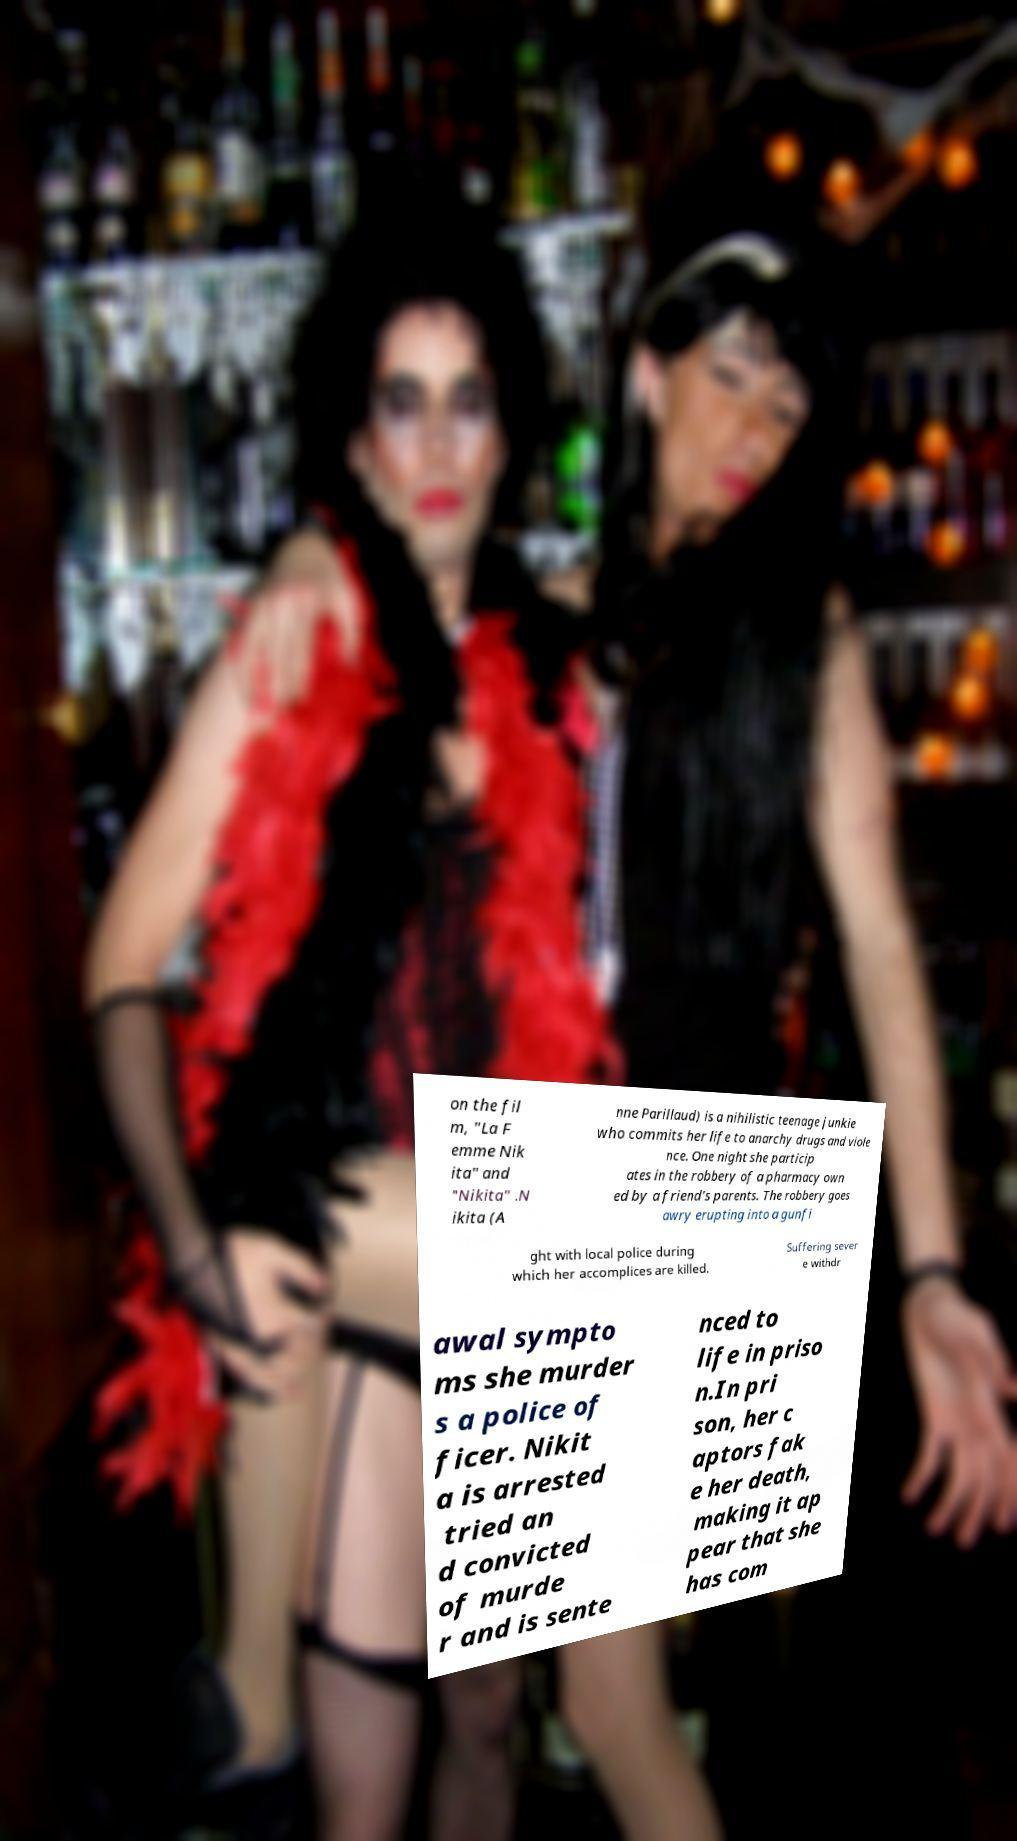Can you accurately transcribe the text from the provided image for me? on the fil m, "La F emme Nik ita" and "Nikita" .N ikita (A nne Parillaud) is a nihilistic teenage junkie who commits her life to anarchy drugs and viole nce. One night she particip ates in the robbery of a pharmacy own ed by a friend's parents. The robbery goes awry erupting into a gunfi ght with local police during which her accomplices are killed. Suffering sever e withdr awal sympto ms she murder s a police of ficer. Nikit a is arrested tried an d convicted of murde r and is sente nced to life in priso n.In pri son, her c aptors fak e her death, making it ap pear that she has com 